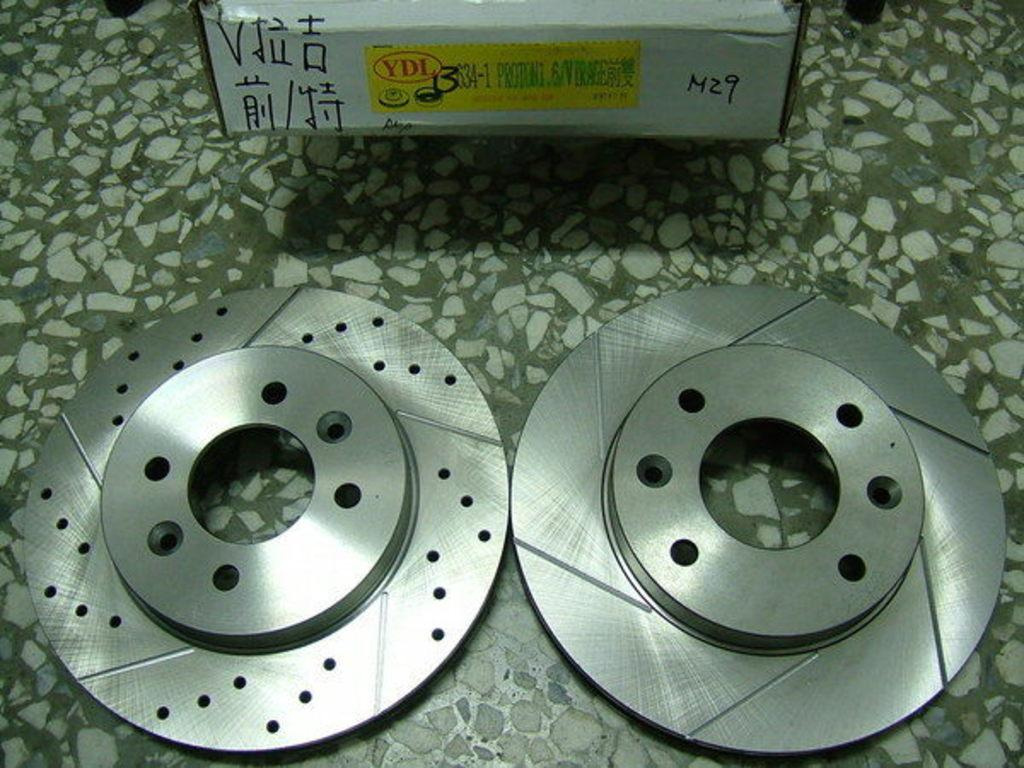What type of brakes are shown in the image? There are disk brakes in the image. Can you describe any other objects in the image? There is a box on the floor in the image. Where is the playground located in the image? There is no playground present in the image. What type of knee injury can be seen in the image? There is no knee or injury present in the image. 